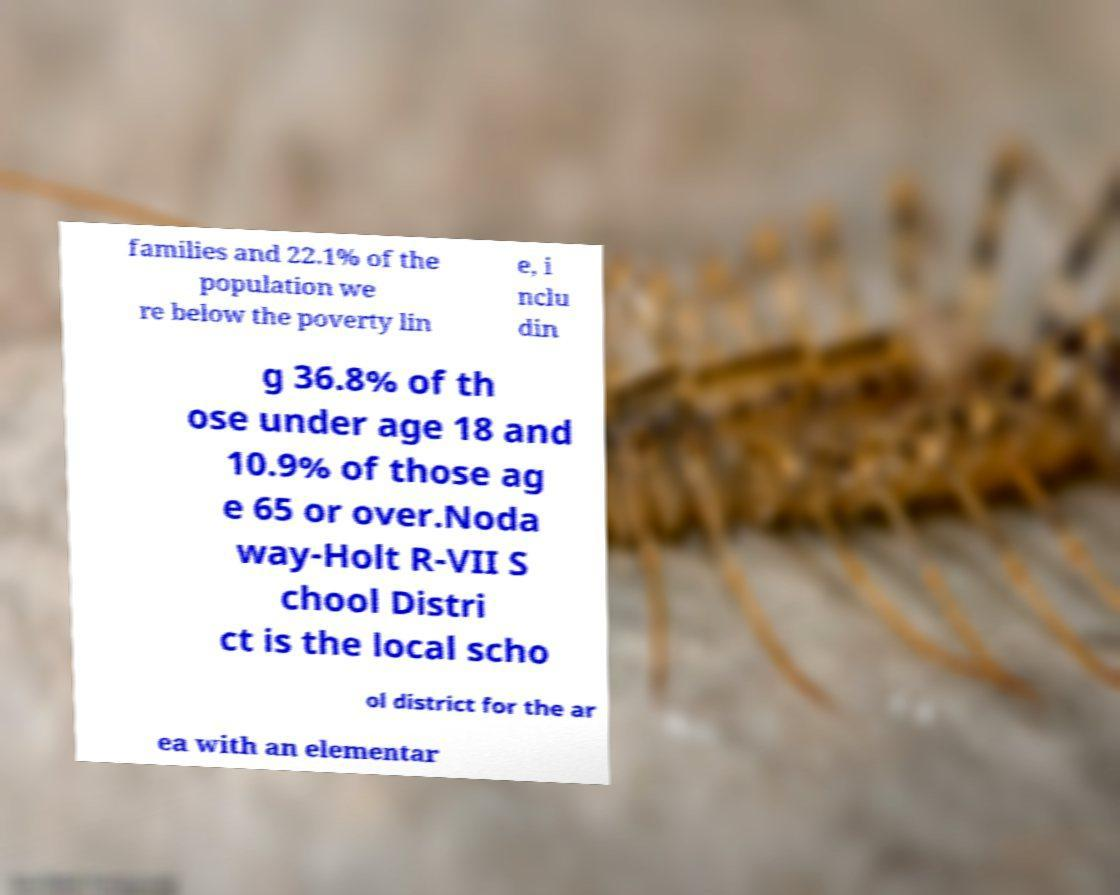What messages or text are displayed in this image? I need them in a readable, typed format. families and 22.1% of the population we re below the poverty lin e, i nclu din g 36.8% of th ose under age 18 and 10.9% of those ag e 65 or over.Noda way-Holt R-VII S chool Distri ct is the local scho ol district for the ar ea with an elementar 